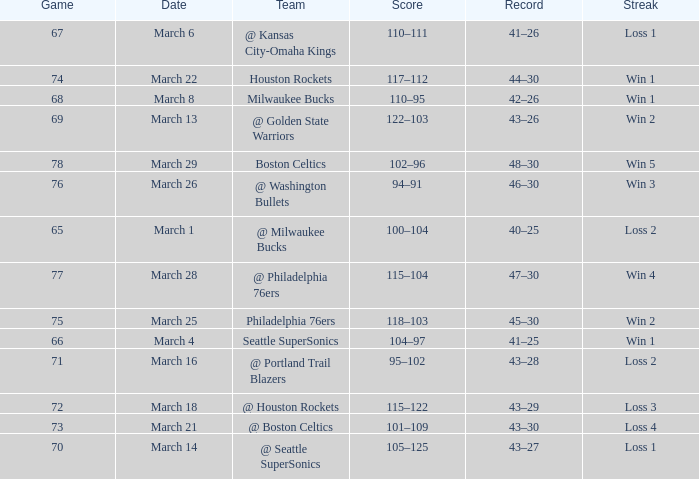What is Team, when Game is 73? @ Boston Celtics. 